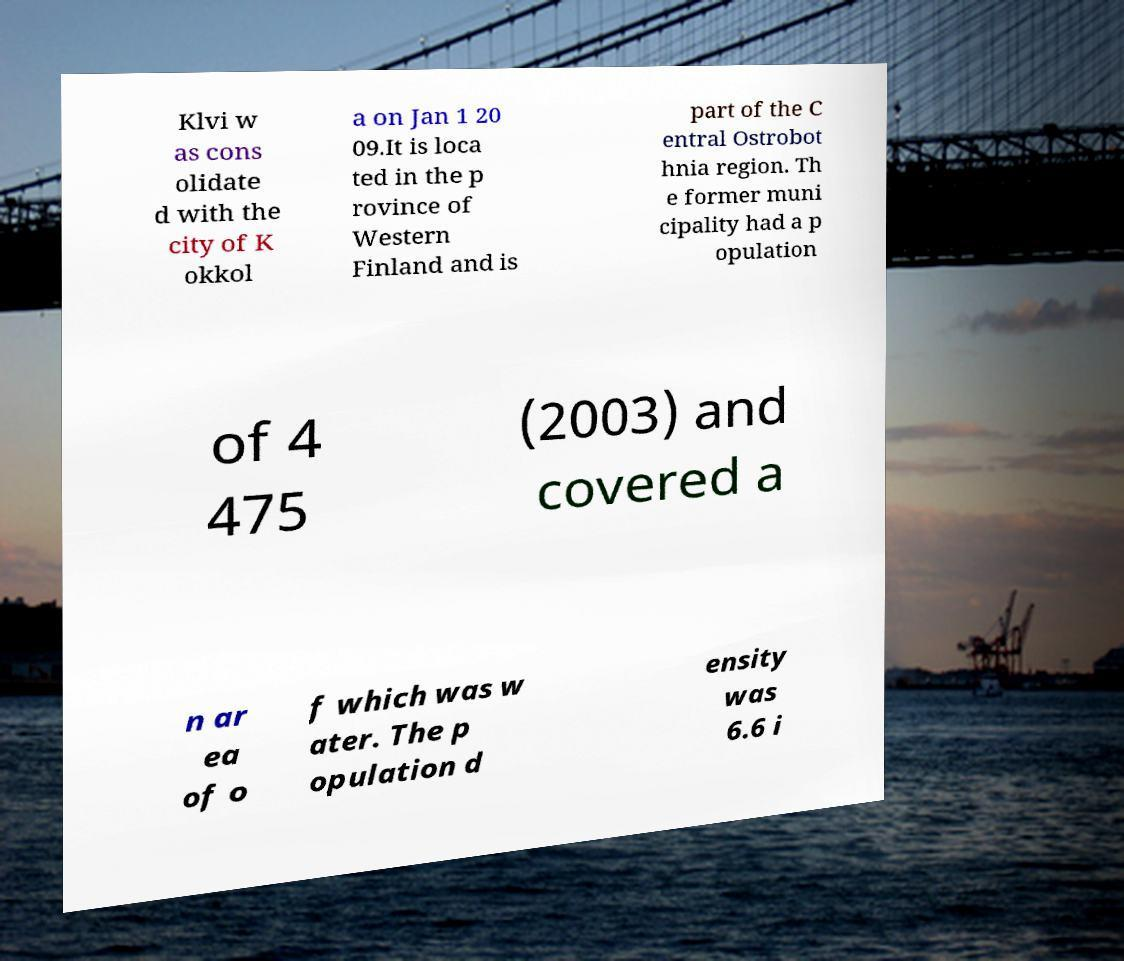Please identify and transcribe the text found in this image. Klvi w as cons olidate d with the city of K okkol a on Jan 1 20 09.It is loca ted in the p rovince of Western Finland and is part of the C entral Ostrobot hnia region. Th e former muni cipality had a p opulation of 4 475 (2003) and covered a n ar ea of o f which was w ater. The p opulation d ensity was 6.6 i 